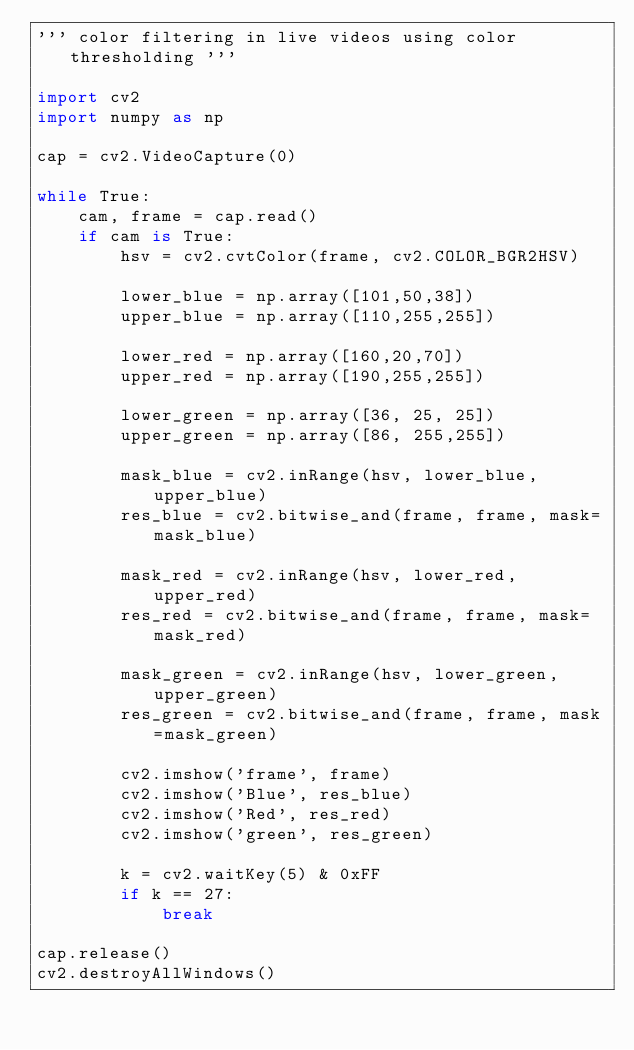Convert code to text. <code><loc_0><loc_0><loc_500><loc_500><_Python_>''' color filtering in live videos using color thresholding '''

import cv2
import numpy as np

cap = cv2.VideoCapture(0)

while True:
    cam, frame = cap.read()
    if cam is True:
        hsv = cv2.cvtColor(frame, cv2.COLOR_BGR2HSV)

        lower_blue = np.array([101,50,38])
        upper_blue = np.array([110,255,255])

        lower_red = np.array([160,20,70])
        upper_red = np.array([190,255,255])

        lower_green = np.array([36, 25, 25])
        upper_green = np.array([86, 255,255])

        mask_blue = cv2.inRange(hsv, lower_blue, upper_blue)
        res_blue = cv2.bitwise_and(frame, frame, mask=mask_blue)

        mask_red = cv2.inRange(hsv, lower_red, upper_red)
        res_red = cv2.bitwise_and(frame, frame, mask=mask_red)

        mask_green = cv2.inRange(hsv, lower_green, upper_green)
        res_green = cv2.bitwise_and(frame, frame, mask=mask_green)

        cv2.imshow('frame', frame)
        cv2.imshow('Blue', res_blue)
        cv2.imshow('Red', res_red)
        cv2.imshow('green', res_green)
        
        k = cv2.waitKey(5) & 0xFF
        if k == 27:
            break

cap.release()
cv2.destroyAllWindows()
</code> 